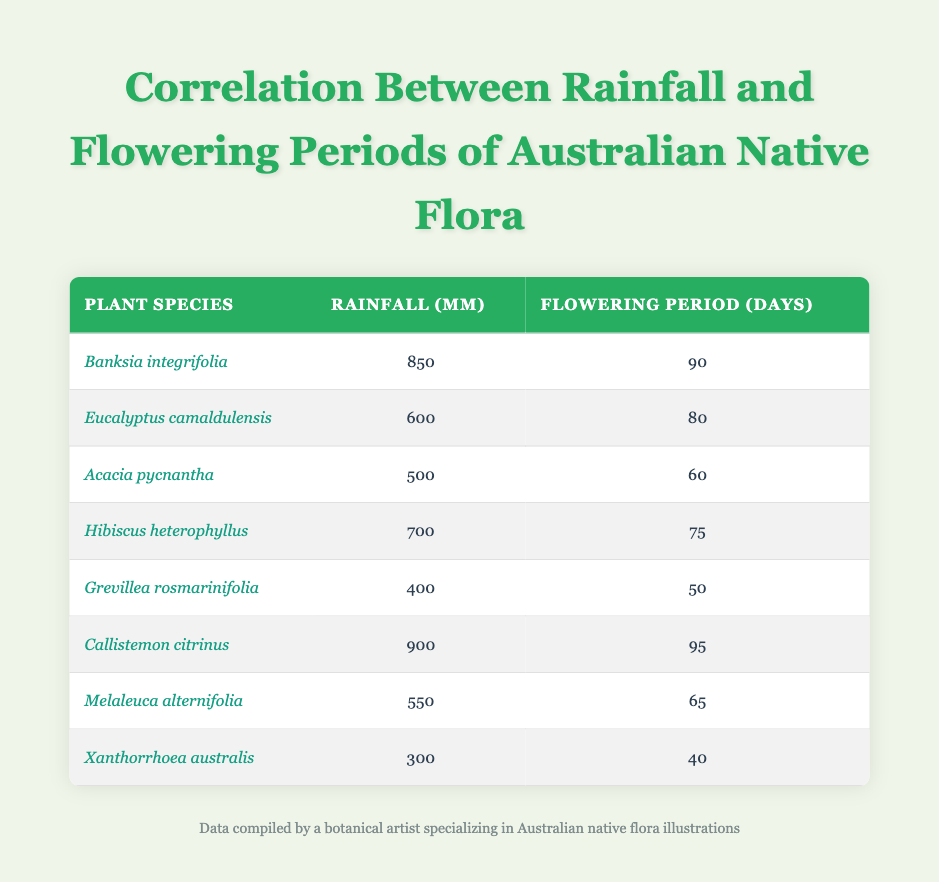What is the rainfall amount for Banksia integrifolia? The table lists the rainfall amount for Banksia integrifolia as 850 mm.
Answer: 850 mm Which plant species has the longest flowering period? Looking at the table, Callistemon citrinus has a flowering period of 95 days, which is the highest among all listed species.
Answer: Callistemon citrinus Is the rainfall amount for Grevillea rosmarinifolia greater than 500 mm? The table shows that Grevillea rosmarinifolia has a rainfall amount of 400 mm, which is less than 500 mm. Thus, the statement is false.
Answer: No What is the average rainfall amount of all species listed in the table? To find the average, sum the rainfall amounts (850 + 600 + 500 + 700 + 400 + 900 + 550 + 300 = 4850) and divide by the number of species (8). The average is 4850 / 8 = 606.25 mm.
Answer: 606.25 mm How many days do Acacia pycnantha and Melaleuca alternifolia flower for combined? Acacia pycnantha flowers for 60 days and Melaleuca alternifolia for 65 days. Adding them together gives 60 + 65 = 125 days.
Answer: 125 days Which species has a rainfall amount closest to the average rainfall derived from all species? First, calculate the average rainfall amount, which is 606.25 mm. The species closest to this is Eucalyptus camaldulensis, with 600 mm, which is only 6.25 mm below the average.
Answer: Eucalyptus camaldulensis Does Xanthorrhoea australis have a longer flowering period than Hibiscus heterophyllus? Xanthorrhoea australis has a flowering period of 40 days, while Hibiscus heterophyllus has a flowering period of 75 days. Therefore, the statement is false.
Answer: No If we compare flowering periods, how many days longer does Callistemon citrinus flower than Xanthorrhoea australis? Callistemon citrinus flowers for 95 days, and Xanthorrhoea australis for 40 days. The difference is 95 - 40 = 55 days.
Answer: 55 days 